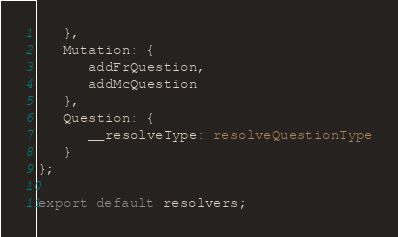<code> <loc_0><loc_0><loc_500><loc_500><_TypeScript_>   },
   Mutation: {
      addFrQuestion,
      addMcQuestion
   },
   Question: {
      __resolveType: resolveQuestionType
   }
};

export default resolvers;
</code> 